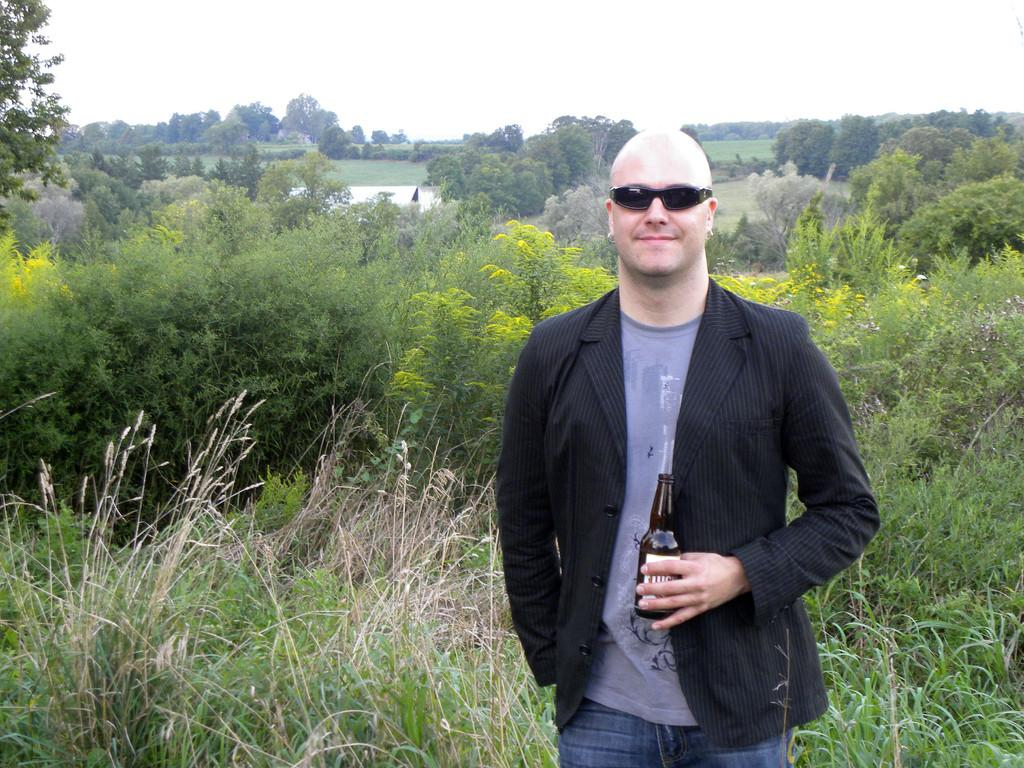Who is present in the image? There is a man in the image. What is the man wearing? The man is wearing a blazer. What object is the man holding in the image? The man is holding a glass bottle. What type of natural environment can be seen in the image? There are trees and water visible in the image. What is visible at the top of the image? The sky is visible at the top of the image. Can you see the man's toe in the image? There is no indication of the man's toe in the image, as the focus is on his upper body and the objects he is holding. 